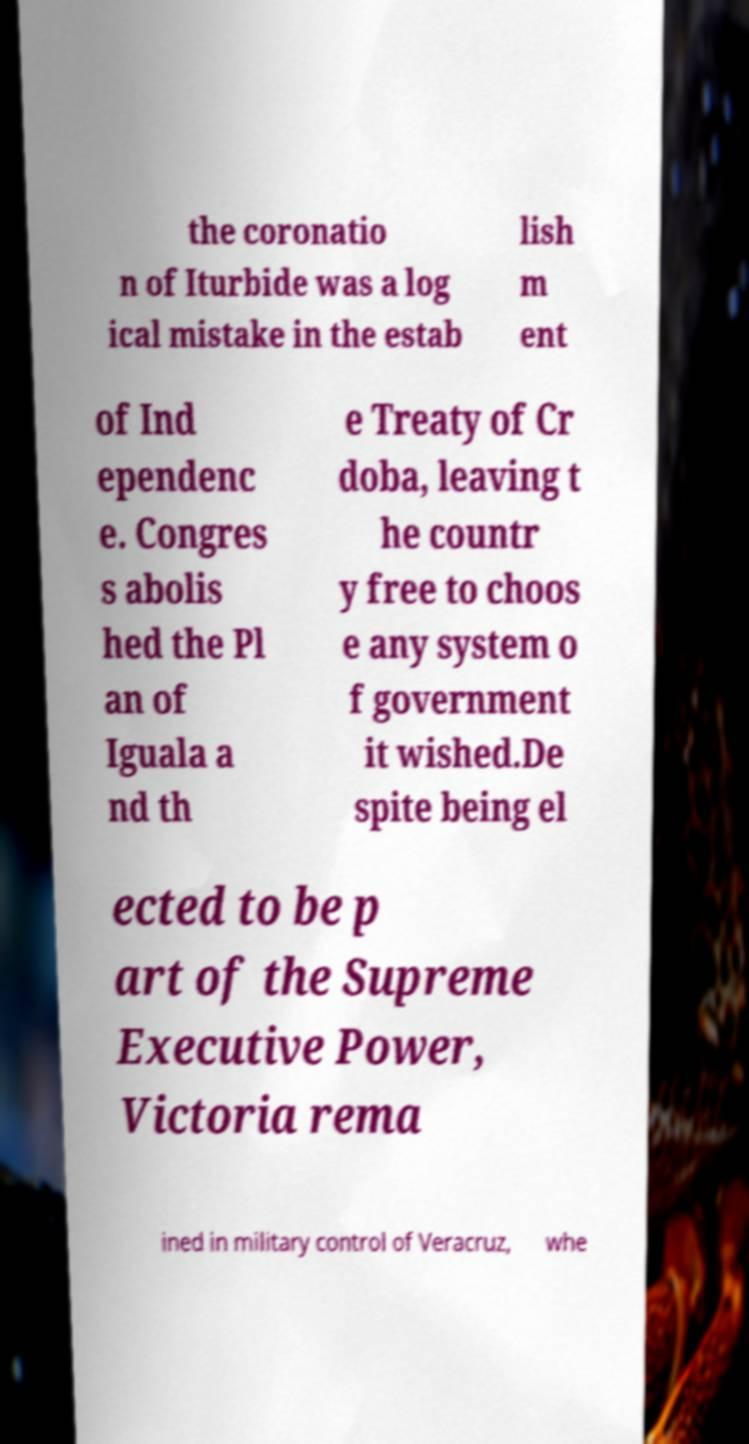For documentation purposes, I need the text within this image transcribed. Could you provide that? the coronatio n of Iturbide was a log ical mistake in the estab lish m ent of Ind ependenc e. Congres s abolis hed the Pl an of Iguala a nd th e Treaty of Cr doba, leaving t he countr y free to choos e any system o f government it wished.De spite being el ected to be p art of the Supreme Executive Power, Victoria rema ined in military control of Veracruz, whe 